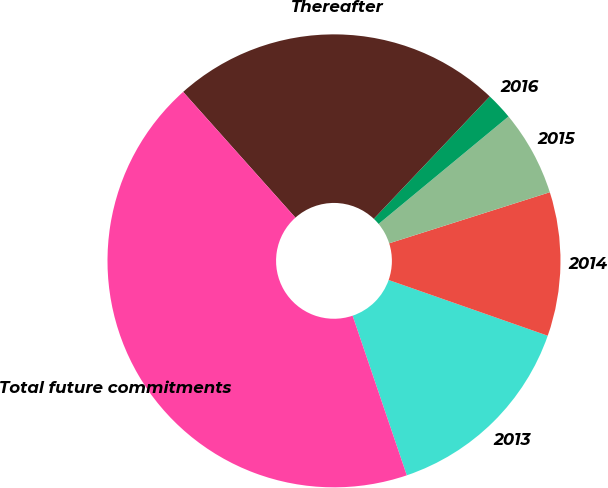Convert chart to OTSL. <chart><loc_0><loc_0><loc_500><loc_500><pie_chart><fcel>2013<fcel>2014<fcel>2015<fcel>2016<fcel>Thereafter<fcel>Total future commitments<nl><fcel>14.43%<fcel>10.26%<fcel>6.1%<fcel>1.93%<fcel>23.67%<fcel>43.61%<nl></chart> 